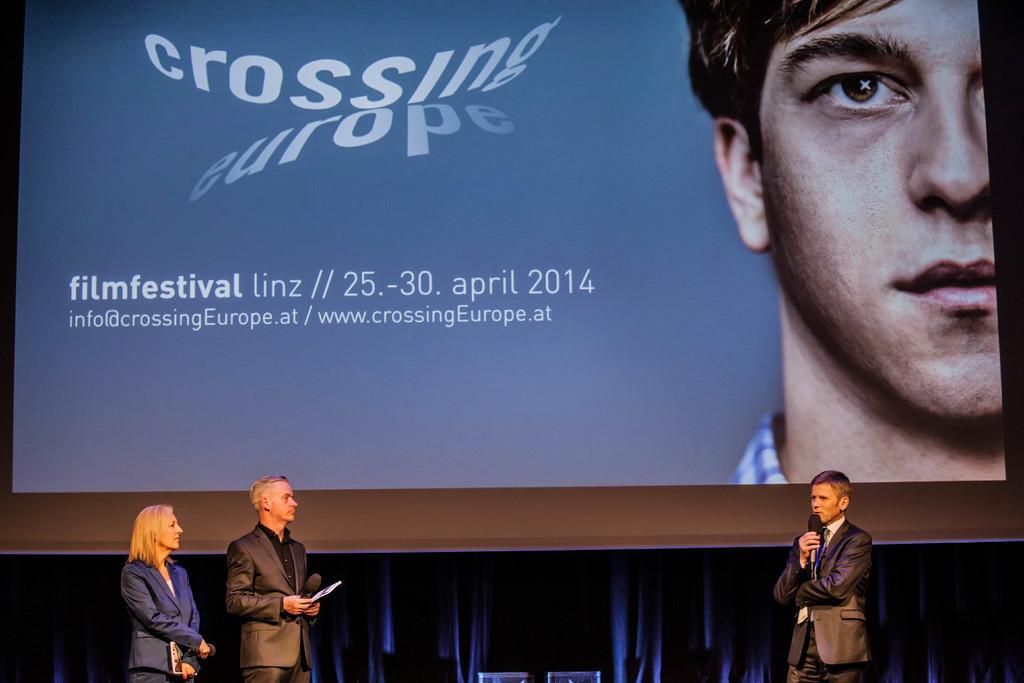In one or two sentences, can you explain what this image depicts? In this image we can see three persons standing and holding the mikes. In the background we can see a screen and on the screen there is text we can also see a person on the screen. 